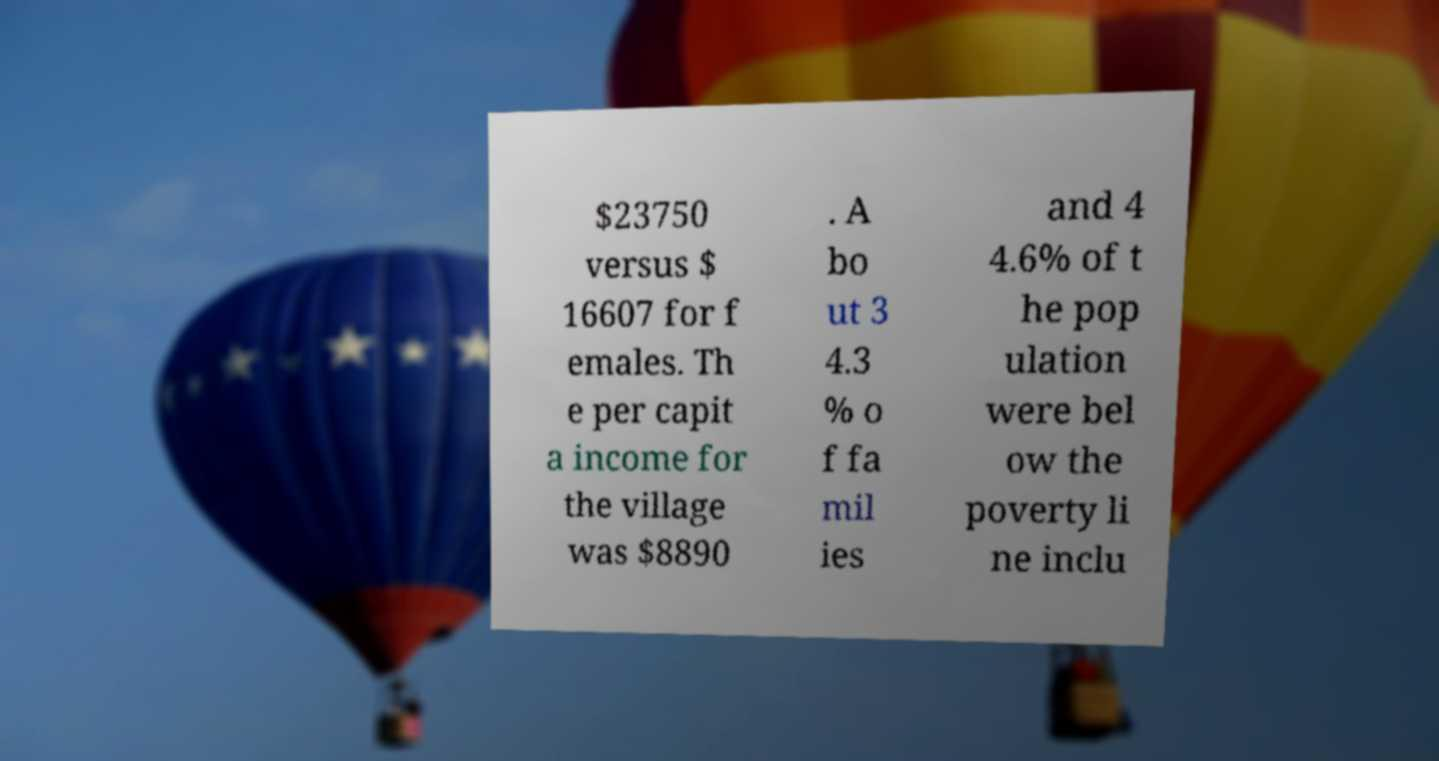There's text embedded in this image that I need extracted. Can you transcribe it verbatim? $23750 versus $ 16607 for f emales. Th e per capit a income for the village was $8890 . A bo ut 3 4.3 % o f fa mil ies and 4 4.6% of t he pop ulation were bel ow the poverty li ne inclu 